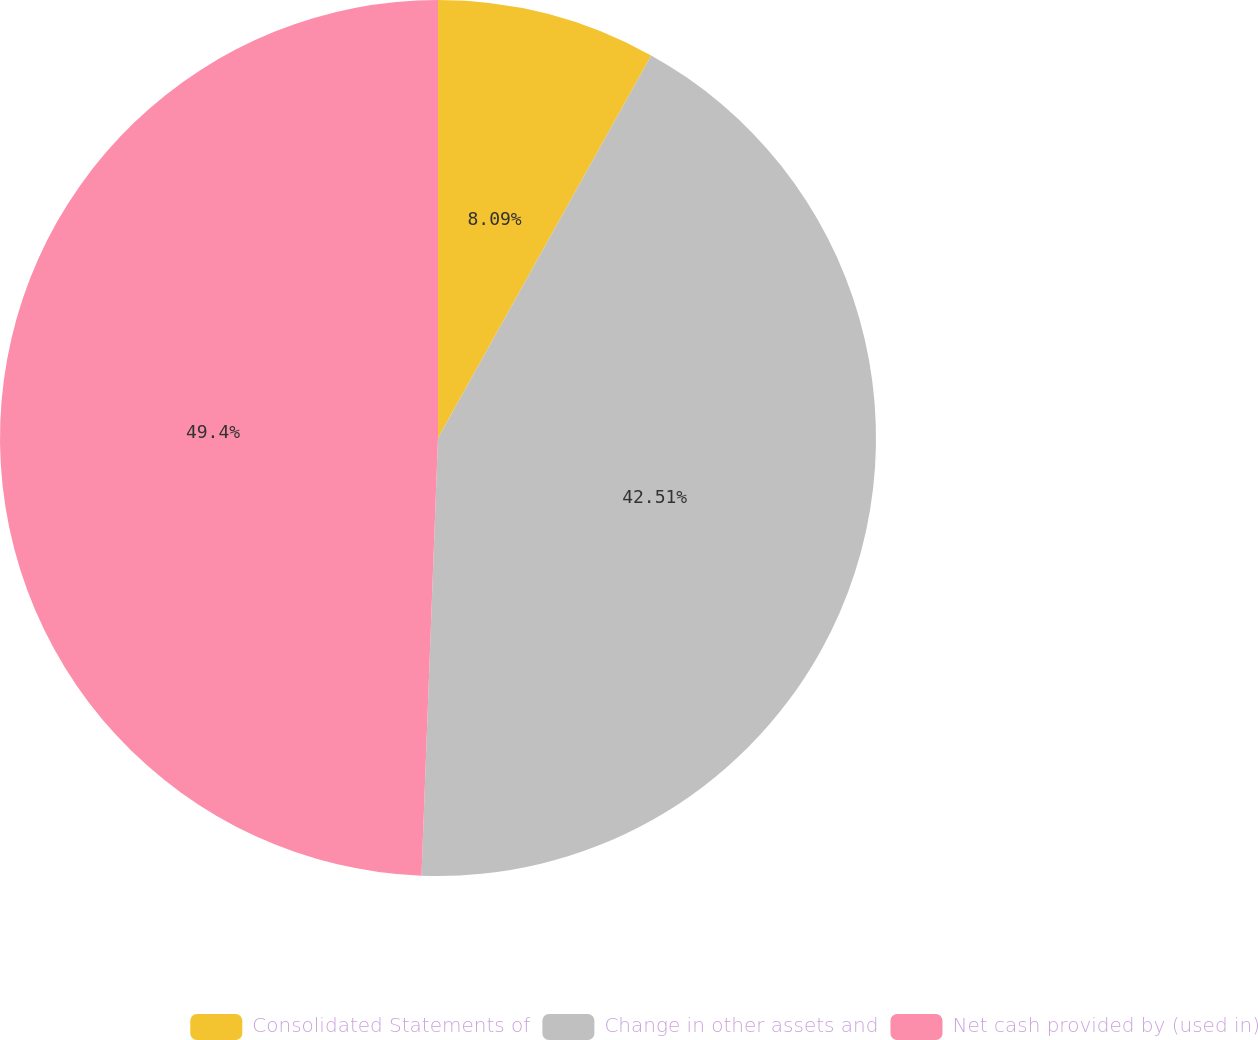Convert chart to OTSL. <chart><loc_0><loc_0><loc_500><loc_500><pie_chart><fcel>Consolidated Statements of<fcel>Change in other assets and<fcel>Net cash provided by (used in)<nl><fcel>8.09%<fcel>42.51%<fcel>49.4%<nl></chart> 